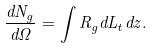Convert formula to latex. <formula><loc_0><loc_0><loc_500><loc_500>\frac { d N _ { g } } { d \Omega } = \int R _ { g } d L _ { t } d z .</formula> 